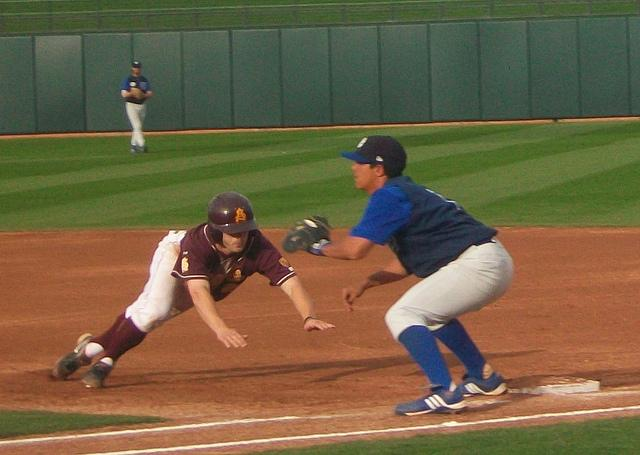What shapes are in the grass? Please explain your reasoning. circled. The grass gets mowed one way and then the opposite. 